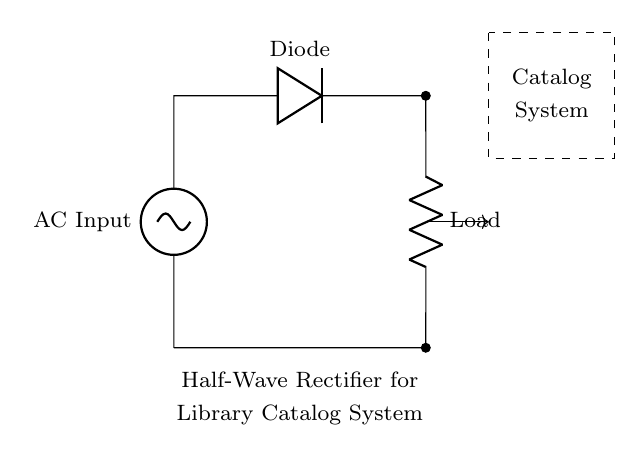What type of rectifier is shown in this circuit? This circuit is a half-wave rectifier as indicated by the presence of a single diode allowing current to pass during only one half of the AC cycle.
Answer: half-wave rectifier What is the function of the diode in this circuit? The diode's function is to allow current to flow in only one direction, converting AC input voltage into pulsating DC output voltage by blocking the negative half of the AC waveform.
Answer: allow current in one direction What type of load does this circuit supply? The load indicated in this circuit typically represents a resistive load, such as could be found in electronic components of a library catalog system, which transforms electrical energy into light, heat, or mechanical energy.
Answer: resistive load How many diodes are present in the circuit? There is one diode in the circuit, depicted by the single diode component connected to the AC input and the load.
Answer: one What happens to the output voltage during the negative half-cycle of the AC input? During the negative half-cycle, the diode becomes reverse-biased, preventing current from passing through, which results in zero output voltage during that period.
Answer: zero output voltage What is the primary purpose of this half-wave rectifier in a library catalog system? The primary purpose is to convert the alternating current (AC) from the power source into direct current (DC) that can be used to power electronic devices or systems in the library catalog system.
Answer: convert AC to DC What component is used to represent the AC input? The component representing the AC input is identified as an AC voltage source in the circuit diagram, providing the alternating current necessary for operation.
Answer: AC voltage source 